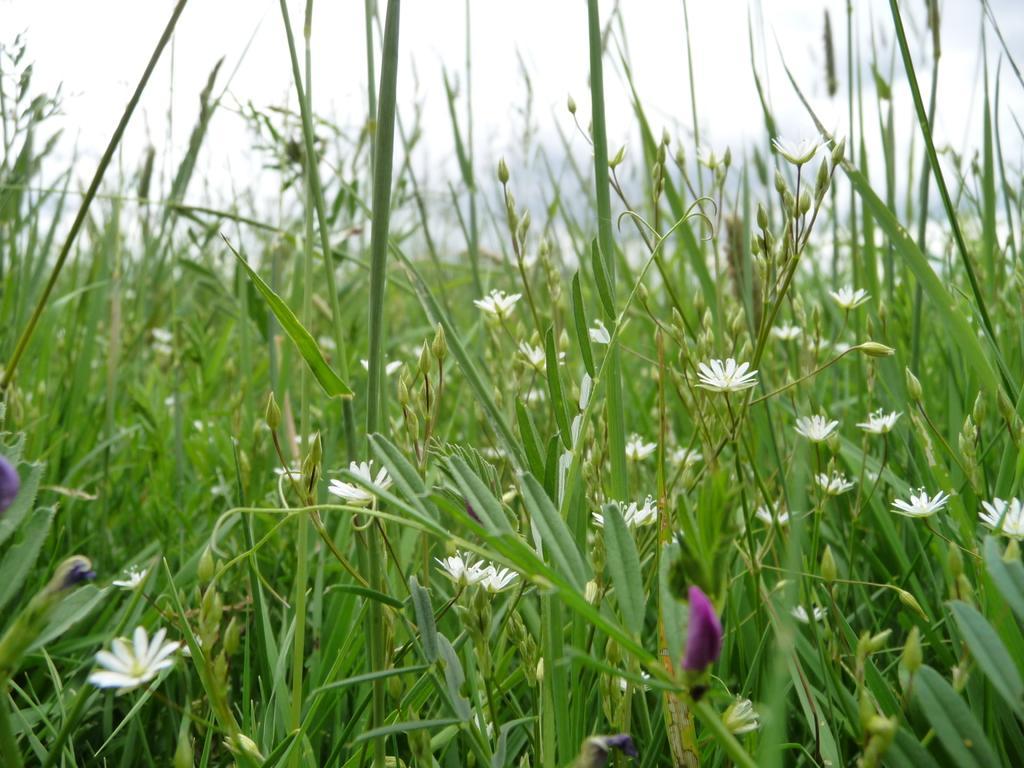Describe this image in one or two sentences. In this picture we can see white flowers and buds. On the top we can see sky. In the back we can see grass. 